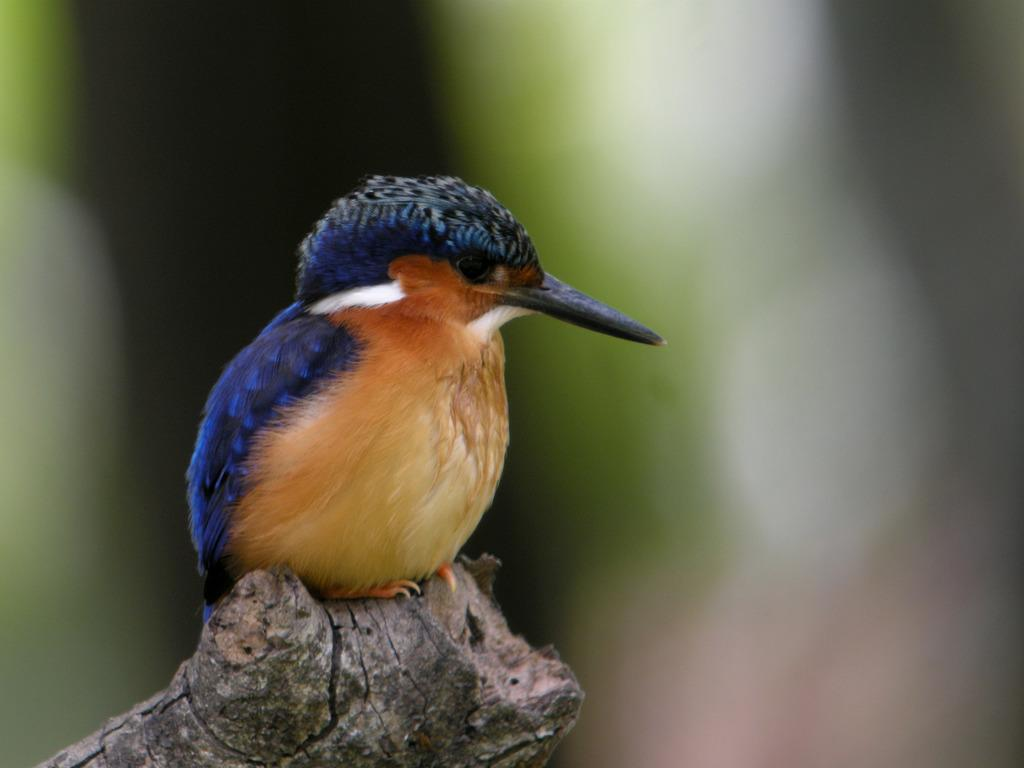What type of animal can be seen in the image? There is a bird in the image. Where is the bird located in the image? The bird is sitting on a branch. What colors can be observed on the bird? The bird has blue, brown, white, and black colors. What colors are present in the background of the image? The background of the image has white, green, and black colors. Is there an island visible in the image? No, there is no island present in the image. Can you see any cords attached to the bird in the image? No, there are no cords visible in the image. 